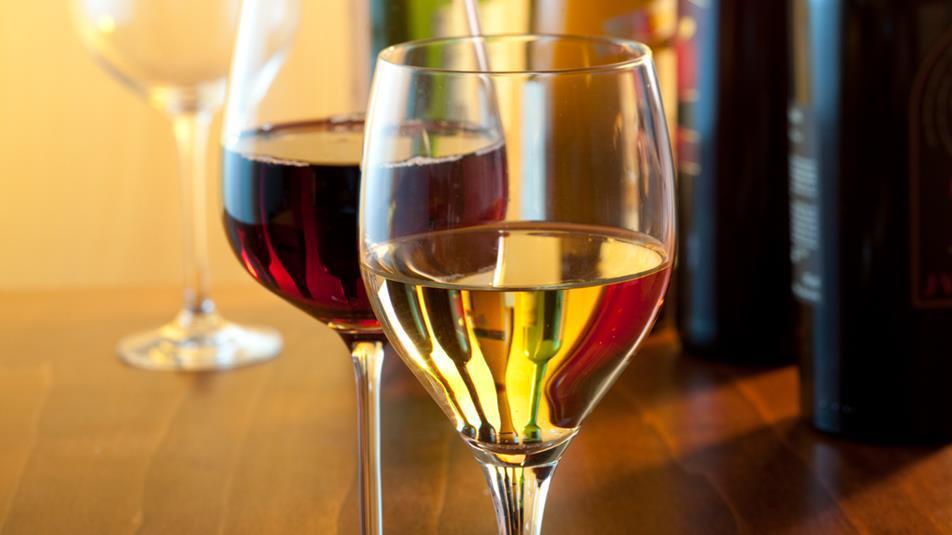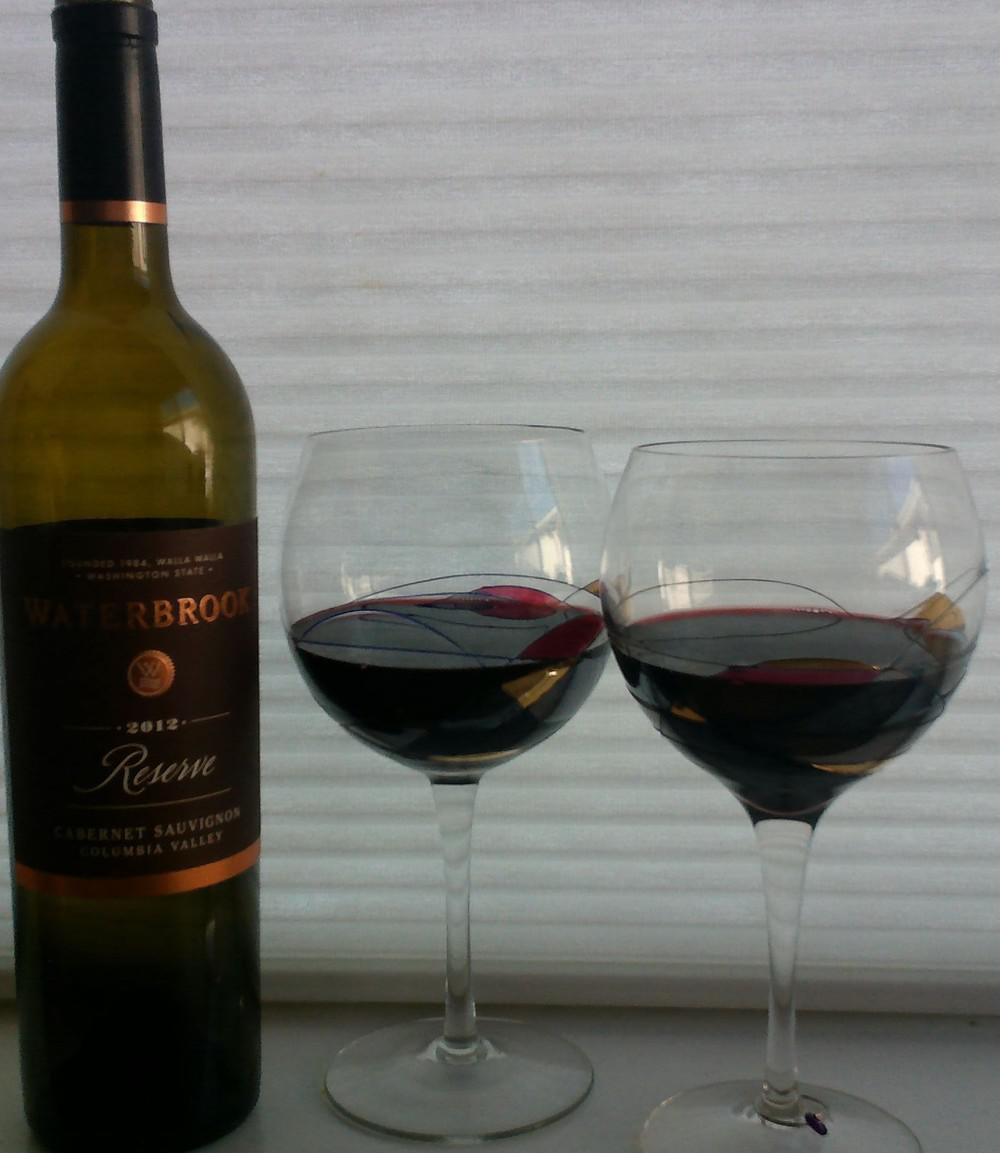The first image is the image on the left, the second image is the image on the right. Given the left and right images, does the statement "The right image has two wine glasses with a bottle of wine to the left of them." hold true? Answer yes or no. Yes. The first image is the image on the left, the second image is the image on the right. Given the left and right images, does the statement "There are two half filled wine glasses next to the bottle in the right image." hold true? Answer yes or no. Yes. 